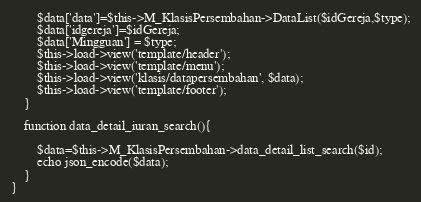Convert code to text. <code><loc_0><loc_0><loc_500><loc_500><_PHP_>		$data['data']=$this->M_KlasisPersembahan->DataList($idGereja,$type);
		$data['idgereja']=$idGereja;
		$data['Mingguan'] = $type;
		$this->load->view('template/header');
		$this->load->view('template/menu');
		$this->load->view('klasis/datapersembahan', $data);
		$this->load->view('template/footer');
	}

	function data_detail_iuran_search(){
  
        $data=$this->M_KlasisPersembahan->data_detail_list_search($id);
        echo json_encode($data);
    }
}</code> 